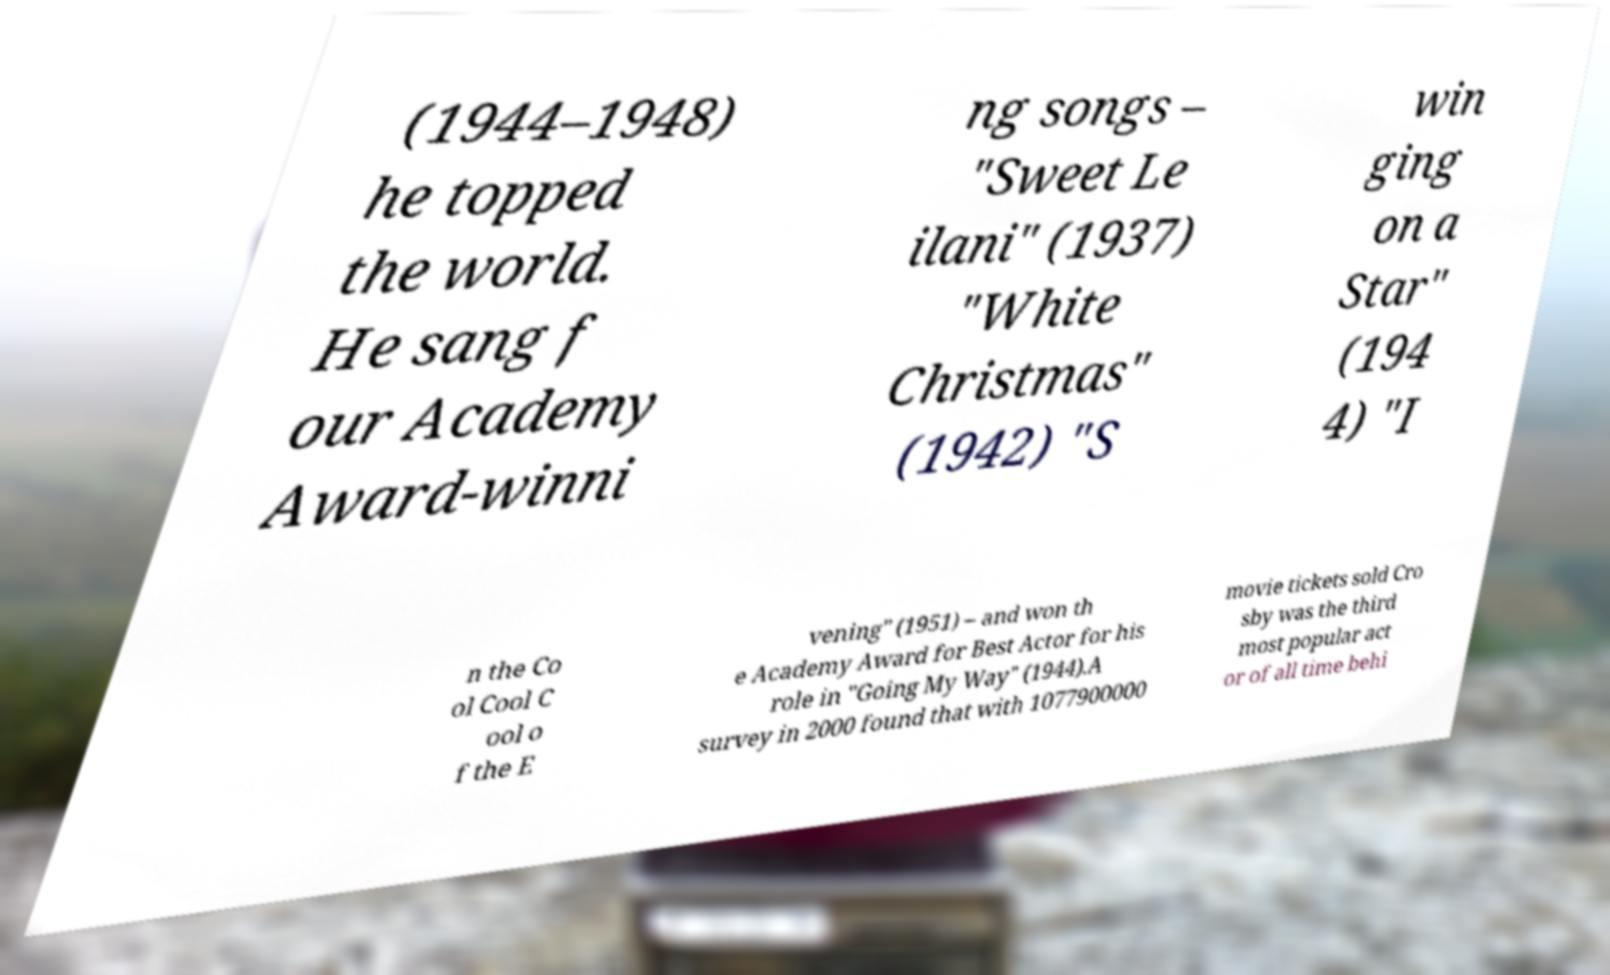Can you accurately transcribe the text from the provided image for me? (1944–1948) he topped the world. He sang f our Academy Award-winni ng songs – "Sweet Le ilani" (1937) "White Christmas" (1942) "S win ging on a Star" (194 4) "I n the Co ol Cool C ool o f the E vening" (1951) – and won th e Academy Award for Best Actor for his role in "Going My Way" (1944).A survey in 2000 found that with 1077900000 movie tickets sold Cro sby was the third most popular act or of all time behi 